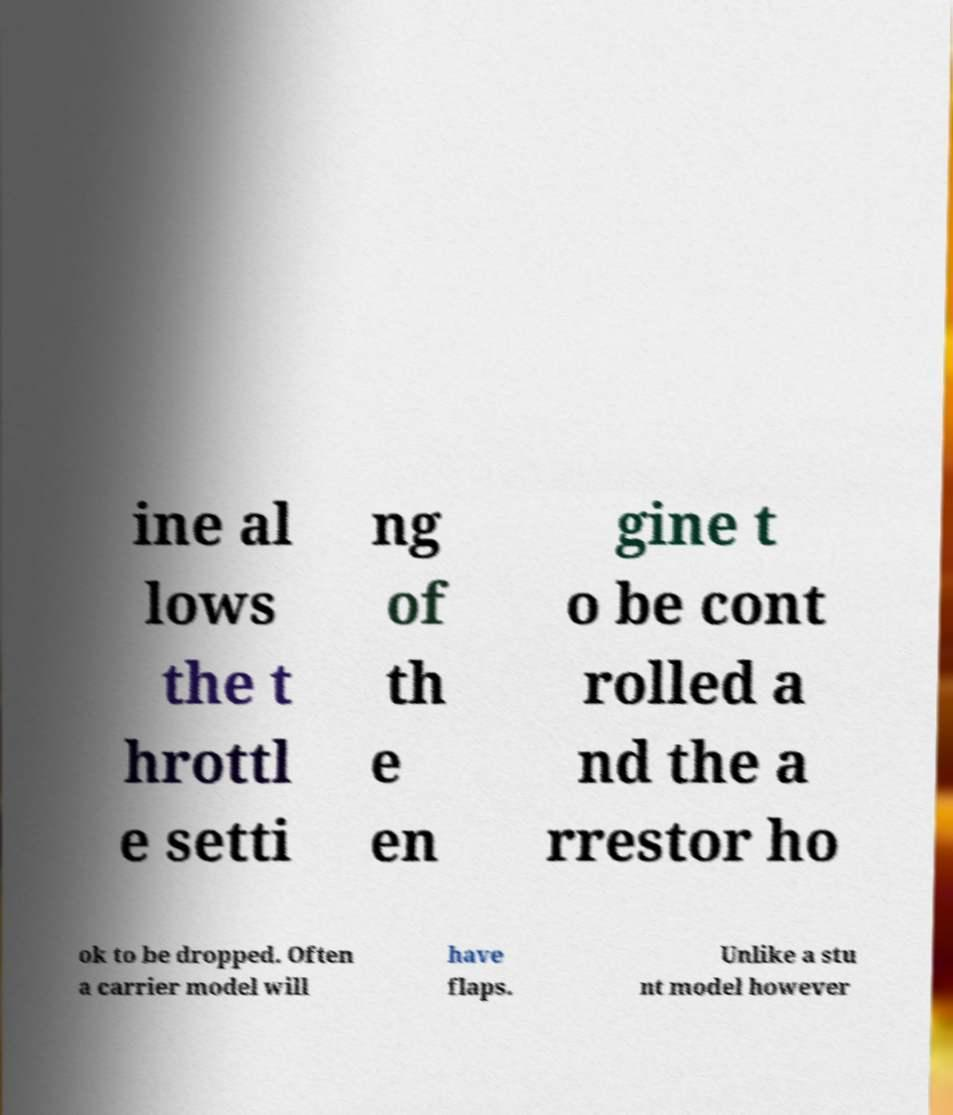Please identify and transcribe the text found in this image. ine al lows the t hrottl e setti ng of th e en gine t o be cont rolled a nd the a rrestor ho ok to be dropped. Often a carrier model will have flaps. Unlike a stu nt model however 